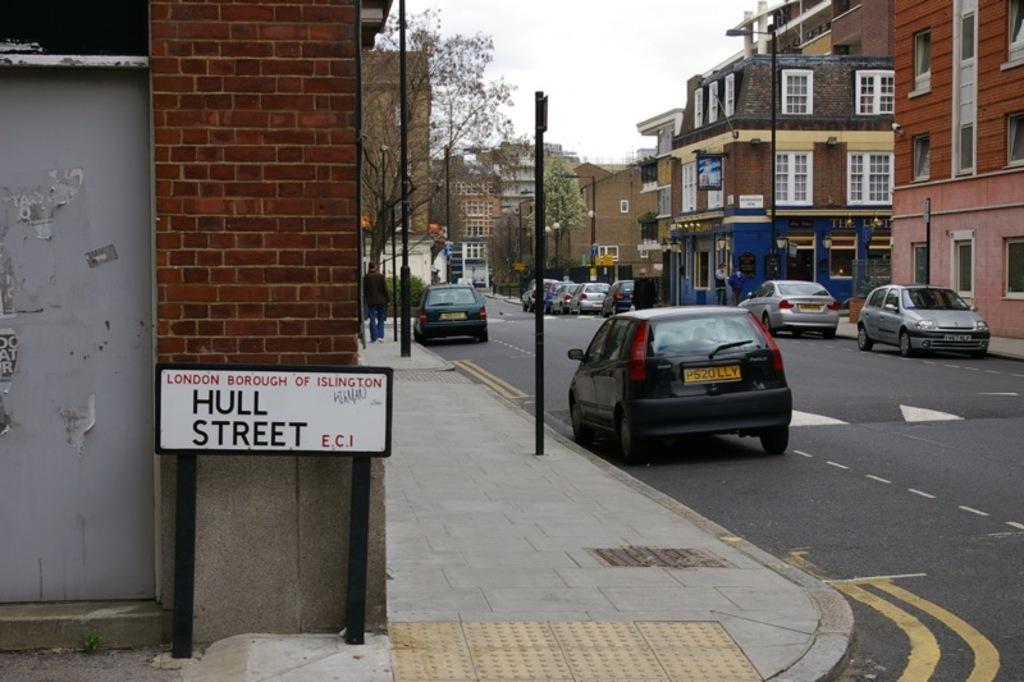Can you describe this image briefly? In this image there is a road on the right side. On the road there are so many cars which are parked on the sidewalk. There are buildings on either side of the road. At the top there is the sky. On the footpath there are poles. On the left side there is a board at the bottom. 